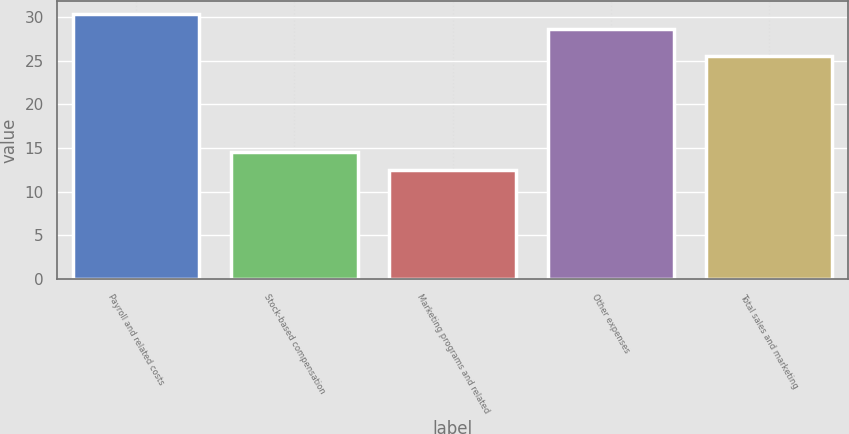Convert chart to OTSL. <chart><loc_0><loc_0><loc_500><loc_500><bar_chart><fcel>Payroll and related costs<fcel>Stock-based compensation<fcel>Marketing programs and related<fcel>Other expenses<fcel>Total sales and marketing<nl><fcel>30.33<fcel>14.5<fcel>12.5<fcel>28.6<fcel>25.5<nl></chart> 